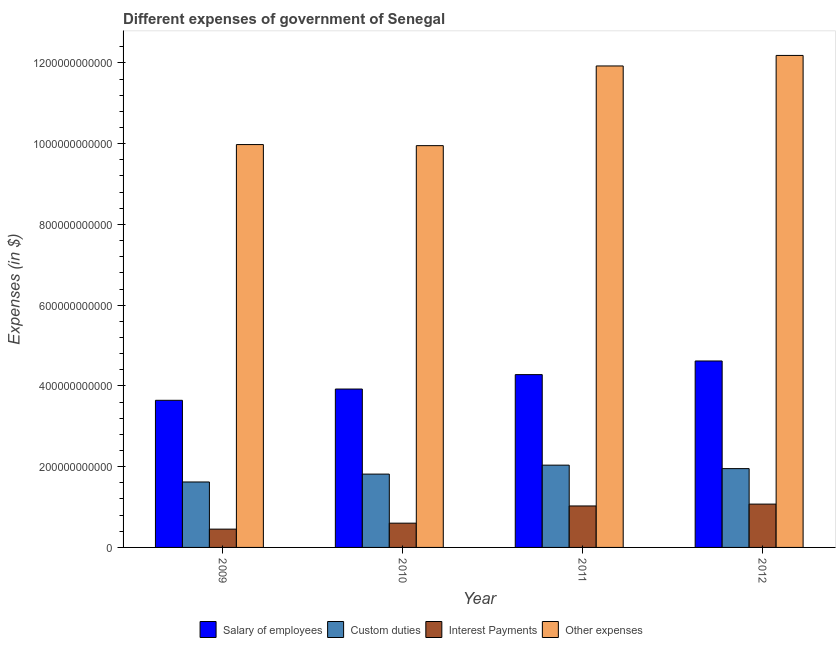How many different coloured bars are there?
Your response must be concise. 4. How many groups of bars are there?
Provide a succinct answer. 4. Are the number of bars on each tick of the X-axis equal?
Your response must be concise. Yes. How many bars are there on the 1st tick from the left?
Provide a short and direct response. 4. How many bars are there on the 4th tick from the right?
Keep it short and to the point. 4. What is the amount spent on custom duties in 2012?
Offer a terse response. 1.95e+11. Across all years, what is the maximum amount spent on custom duties?
Offer a terse response. 2.04e+11. Across all years, what is the minimum amount spent on interest payments?
Ensure brevity in your answer.  4.53e+1. In which year was the amount spent on interest payments maximum?
Your answer should be very brief. 2012. What is the total amount spent on salary of employees in the graph?
Offer a very short reply. 1.65e+12. What is the difference between the amount spent on other expenses in 2011 and that in 2012?
Your response must be concise. -2.61e+1. What is the difference between the amount spent on salary of employees in 2010 and the amount spent on interest payments in 2012?
Keep it short and to the point. -6.95e+1. What is the average amount spent on custom duties per year?
Keep it short and to the point. 1.86e+11. In the year 2010, what is the difference between the amount spent on interest payments and amount spent on salary of employees?
Provide a succinct answer. 0. In how many years, is the amount spent on interest payments greater than 760000000000 $?
Offer a terse response. 0. What is the ratio of the amount spent on salary of employees in 2010 to that in 2011?
Your answer should be compact. 0.92. What is the difference between the highest and the second highest amount spent on salary of employees?
Provide a succinct answer. 3.38e+1. What is the difference between the highest and the lowest amount spent on interest payments?
Keep it short and to the point. 6.20e+1. In how many years, is the amount spent on salary of employees greater than the average amount spent on salary of employees taken over all years?
Ensure brevity in your answer.  2. Is the sum of the amount spent on salary of employees in 2010 and 2012 greater than the maximum amount spent on interest payments across all years?
Make the answer very short. Yes. What does the 3rd bar from the left in 2012 represents?
Your response must be concise. Interest Payments. What does the 2nd bar from the right in 2009 represents?
Keep it short and to the point. Interest Payments. What is the difference between two consecutive major ticks on the Y-axis?
Offer a terse response. 2.00e+11. Are the values on the major ticks of Y-axis written in scientific E-notation?
Keep it short and to the point. No. Does the graph contain any zero values?
Your answer should be compact. No. How are the legend labels stacked?
Your answer should be very brief. Horizontal. What is the title of the graph?
Provide a succinct answer. Different expenses of government of Senegal. Does "Mammal species" appear as one of the legend labels in the graph?
Your answer should be very brief. No. What is the label or title of the Y-axis?
Your response must be concise. Expenses (in $). What is the Expenses (in $) of Salary of employees in 2009?
Your response must be concise. 3.64e+11. What is the Expenses (in $) in Custom duties in 2009?
Your answer should be compact. 1.62e+11. What is the Expenses (in $) of Interest Payments in 2009?
Your answer should be compact. 4.53e+1. What is the Expenses (in $) in Other expenses in 2009?
Provide a short and direct response. 9.98e+11. What is the Expenses (in $) in Salary of employees in 2010?
Give a very brief answer. 3.92e+11. What is the Expenses (in $) in Custom duties in 2010?
Your answer should be compact. 1.82e+11. What is the Expenses (in $) of Interest Payments in 2010?
Provide a short and direct response. 6.01e+1. What is the Expenses (in $) in Other expenses in 2010?
Make the answer very short. 9.95e+11. What is the Expenses (in $) of Salary of employees in 2011?
Keep it short and to the point. 4.28e+11. What is the Expenses (in $) in Custom duties in 2011?
Your answer should be very brief. 2.04e+11. What is the Expenses (in $) of Interest Payments in 2011?
Provide a succinct answer. 1.03e+11. What is the Expenses (in $) in Other expenses in 2011?
Make the answer very short. 1.19e+12. What is the Expenses (in $) of Salary of employees in 2012?
Give a very brief answer. 4.62e+11. What is the Expenses (in $) of Custom duties in 2012?
Make the answer very short. 1.95e+11. What is the Expenses (in $) of Interest Payments in 2012?
Your answer should be very brief. 1.07e+11. What is the Expenses (in $) in Other expenses in 2012?
Your response must be concise. 1.22e+12. Across all years, what is the maximum Expenses (in $) in Salary of employees?
Provide a succinct answer. 4.62e+11. Across all years, what is the maximum Expenses (in $) of Custom duties?
Your answer should be compact. 2.04e+11. Across all years, what is the maximum Expenses (in $) in Interest Payments?
Your answer should be compact. 1.07e+11. Across all years, what is the maximum Expenses (in $) of Other expenses?
Your response must be concise. 1.22e+12. Across all years, what is the minimum Expenses (in $) in Salary of employees?
Ensure brevity in your answer.  3.64e+11. Across all years, what is the minimum Expenses (in $) in Custom duties?
Offer a very short reply. 1.62e+11. Across all years, what is the minimum Expenses (in $) in Interest Payments?
Offer a terse response. 4.53e+1. Across all years, what is the minimum Expenses (in $) of Other expenses?
Offer a very short reply. 9.95e+11. What is the total Expenses (in $) in Salary of employees in the graph?
Your answer should be compact. 1.65e+12. What is the total Expenses (in $) in Custom duties in the graph?
Your answer should be compact. 7.43e+11. What is the total Expenses (in $) of Interest Payments in the graph?
Give a very brief answer. 3.15e+11. What is the total Expenses (in $) in Other expenses in the graph?
Offer a very short reply. 4.40e+12. What is the difference between the Expenses (in $) of Salary of employees in 2009 and that in 2010?
Provide a short and direct response. -2.79e+1. What is the difference between the Expenses (in $) in Custom duties in 2009 and that in 2010?
Your answer should be very brief. -1.95e+1. What is the difference between the Expenses (in $) in Interest Payments in 2009 and that in 2010?
Your answer should be very brief. -1.48e+1. What is the difference between the Expenses (in $) of Other expenses in 2009 and that in 2010?
Provide a short and direct response. 2.67e+09. What is the difference between the Expenses (in $) of Salary of employees in 2009 and that in 2011?
Keep it short and to the point. -6.36e+1. What is the difference between the Expenses (in $) of Custom duties in 2009 and that in 2011?
Make the answer very short. -4.17e+1. What is the difference between the Expenses (in $) in Interest Payments in 2009 and that in 2011?
Provide a short and direct response. -5.74e+1. What is the difference between the Expenses (in $) in Other expenses in 2009 and that in 2011?
Give a very brief answer. -1.95e+11. What is the difference between the Expenses (in $) in Salary of employees in 2009 and that in 2012?
Your response must be concise. -9.74e+1. What is the difference between the Expenses (in $) of Custom duties in 2009 and that in 2012?
Your response must be concise. -3.31e+1. What is the difference between the Expenses (in $) in Interest Payments in 2009 and that in 2012?
Keep it short and to the point. -6.20e+1. What is the difference between the Expenses (in $) in Other expenses in 2009 and that in 2012?
Offer a terse response. -2.21e+11. What is the difference between the Expenses (in $) in Salary of employees in 2010 and that in 2011?
Provide a short and direct response. -3.57e+1. What is the difference between the Expenses (in $) in Custom duties in 2010 and that in 2011?
Provide a short and direct response. -2.22e+1. What is the difference between the Expenses (in $) of Interest Payments in 2010 and that in 2011?
Ensure brevity in your answer.  -4.26e+1. What is the difference between the Expenses (in $) in Other expenses in 2010 and that in 2011?
Provide a short and direct response. -1.97e+11. What is the difference between the Expenses (in $) of Salary of employees in 2010 and that in 2012?
Offer a very short reply. -6.95e+1. What is the difference between the Expenses (in $) in Custom duties in 2010 and that in 2012?
Offer a very short reply. -1.36e+1. What is the difference between the Expenses (in $) of Interest Payments in 2010 and that in 2012?
Offer a terse response. -4.72e+1. What is the difference between the Expenses (in $) in Other expenses in 2010 and that in 2012?
Keep it short and to the point. -2.23e+11. What is the difference between the Expenses (in $) in Salary of employees in 2011 and that in 2012?
Your response must be concise. -3.38e+1. What is the difference between the Expenses (in $) in Custom duties in 2011 and that in 2012?
Your response must be concise. 8.60e+09. What is the difference between the Expenses (in $) in Interest Payments in 2011 and that in 2012?
Your response must be concise. -4.60e+09. What is the difference between the Expenses (in $) in Other expenses in 2011 and that in 2012?
Offer a terse response. -2.61e+1. What is the difference between the Expenses (in $) of Salary of employees in 2009 and the Expenses (in $) of Custom duties in 2010?
Offer a very short reply. 1.83e+11. What is the difference between the Expenses (in $) in Salary of employees in 2009 and the Expenses (in $) in Interest Payments in 2010?
Your response must be concise. 3.04e+11. What is the difference between the Expenses (in $) in Salary of employees in 2009 and the Expenses (in $) in Other expenses in 2010?
Make the answer very short. -6.31e+11. What is the difference between the Expenses (in $) of Custom duties in 2009 and the Expenses (in $) of Interest Payments in 2010?
Make the answer very short. 1.02e+11. What is the difference between the Expenses (in $) of Custom duties in 2009 and the Expenses (in $) of Other expenses in 2010?
Your answer should be compact. -8.33e+11. What is the difference between the Expenses (in $) in Interest Payments in 2009 and the Expenses (in $) in Other expenses in 2010?
Offer a terse response. -9.50e+11. What is the difference between the Expenses (in $) of Salary of employees in 2009 and the Expenses (in $) of Custom duties in 2011?
Offer a very short reply. 1.61e+11. What is the difference between the Expenses (in $) of Salary of employees in 2009 and the Expenses (in $) of Interest Payments in 2011?
Provide a succinct answer. 2.62e+11. What is the difference between the Expenses (in $) of Salary of employees in 2009 and the Expenses (in $) of Other expenses in 2011?
Provide a short and direct response. -8.28e+11. What is the difference between the Expenses (in $) in Custom duties in 2009 and the Expenses (in $) in Interest Payments in 2011?
Your response must be concise. 5.94e+1. What is the difference between the Expenses (in $) of Custom duties in 2009 and the Expenses (in $) of Other expenses in 2011?
Offer a terse response. -1.03e+12. What is the difference between the Expenses (in $) in Interest Payments in 2009 and the Expenses (in $) in Other expenses in 2011?
Offer a very short reply. -1.15e+12. What is the difference between the Expenses (in $) of Salary of employees in 2009 and the Expenses (in $) of Custom duties in 2012?
Offer a very short reply. 1.69e+11. What is the difference between the Expenses (in $) of Salary of employees in 2009 and the Expenses (in $) of Interest Payments in 2012?
Provide a short and direct response. 2.57e+11. What is the difference between the Expenses (in $) in Salary of employees in 2009 and the Expenses (in $) in Other expenses in 2012?
Ensure brevity in your answer.  -8.54e+11. What is the difference between the Expenses (in $) in Custom duties in 2009 and the Expenses (in $) in Interest Payments in 2012?
Your response must be concise. 5.48e+1. What is the difference between the Expenses (in $) in Custom duties in 2009 and the Expenses (in $) in Other expenses in 2012?
Offer a terse response. -1.06e+12. What is the difference between the Expenses (in $) of Interest Payments in 2009 and the Expenses (in $) of Other expenses in 2012?
Provide a short and direct response. -1.17e+12. What is the difference between the Expenses (in $) in Salary of employees in 2010 and the Expenses (in $) in Custom duties in 2011?
Offer a terse response. 1.89e+11. What is the difference between the Expenses (in $) in Salary of employees in 2010 and the Expenses (in $) in Interest Payments in 2011?
Give a very brief answer. 2.90e+11. What is the difference between the Expenses (in $) in Salary of employees in 2010 and the Expenses (in $) in Other expenses in 2011?
Ensure brevity in your answer.  -8.00e+11. What is the difference between the Expenses (in $) in Custom duties in 2010 and the Expenses (in $) in Interest Payments in 2011?
Give a very brief answer. 7.89e+1. What is the difference between the Expenses (in $) in Custom duties in 2010 and the Expenses (in $) in Other expenses in 2011?
Keep it short and to the point. -1.01e+12. What is the difference between the Expenses (in $) of Interest Payments in 2010 and the Expenses (in $) of Other expenses in 2011?
Make the answer very short. -1.13e+12. What is the difference between the Expenses (in $) of Salary of employees in 2010 and the Expenses (in $) of Custom duties in 2012?
Your answer should be compact. 1.97e+11. What is the difference between the Expenses (in $) of Salary of employees in 2010 and the Expenses (in $) of Interest Payments in 2012?
Offer a terse response. 2.85e+11. What is the difference between the Expenses (in $) in Salary of employees in 2010 and the Expenses (in $) in Other expenses in 2012?
Your answer should be very brief. -8.26e+11. What is the difference between the Expenses (in $) in Custom duties in 2010 and the Expenses (in $) in Interest Payments in 2012?
Ensure brevity in your answer.  7.43e+1. What is the difference between the Expenses (in $) of Custom duties in 2010 and the Expenses (in $) of Other expenses in 2012?
Your answer should be very brief. -1.04e+12. What is the difference between the Expenses (in $) in Interest Payments in 2010 and the Expenses (in $) in Other expenses in 2012?
Provide a short and direct response. -1.16e+12. What is the difference between the Expenses (in $) in Salary of employees in 2011 and the Expenses (in $) in Custom duties in 2012?
Provide a short and direct response. 2.33e+11. What is the difference between the Expenses (in $) in Salary of employees in 2011 and the Expenses (in $) in Interest Payments in 2012?
Provide a short and direct response. 3.21e+11. What is the difference between the Expenses (in $) in Salary of employees in 2011 and the Expenses (in $) in Other expenses in 2012?
Provide a succinct answer. -7.91e+11. What is the difference between the Expenses (in $) of Custom duties in 2011 and the Expenses (in $) of Interest Payments in 2012?
Ensure brevity in your answer.  9.65e+1. What is the difference between the Expenses (in $) of Custom duties in 2011 and the Expenses (in $) of Other expenses in 2012?
Offer a very short reply. -1.01e+12. What is the difference between the Expenses (in $) in Interest Payments in 2011 and the Expenses (in $) in Other expenses in 2012?
Offer a very short reply. -1.12e+12. What is the average Expenses (in $) in Salary of employees per year?
Give a very brief answer. 4.12e+11. What is the average Expenses (in $) in Custom duties per year?
Offer a terse response. 1.86e+11. What is the average Expenses (in $) of Interest Payments per year?
Your answer should be compact. 7.88e+1. What is the average Expenses (in $) in Other expenses per year?
Your answer should be very brief. 1.10e+12. In the year 2009, what is the difference between the Expenses (in $) in Salary of employees and Expenses (in $) in Custom duties?
Offer a very short reply. 2.02e+11. In the year 2009, what is the difference between the Expenses (in $) in Salary of employees and Expenses (in $) in Interest Payments?
Keep it short and to the point. 3.19e+11. In the year 2009, what is the difference between the Expenses (in $) of Salary of employees and Expenses (in $) of Other expenses?
Your answer should be very brief. -6.33e+11. In the year 2009, what is the difference between the Expenses (in $) of Custom duties and Expenses (in $) of Interest Payments?
Offer a terse response. 1.17e+11. In the year 2009, what is the difference between the Expenses (in $) in Custom duties and Expenses (in $) in Other expenses?
Keep it short and to the point. -8.36e+11. In the year 2009, what is the difference between the Expenses (in $) in Interest Payments and Expenses (in $) in Other expenses?
Offer a terse response. -9.52e+11. In the year 2010, what is the difference between the Expenses (in $) of Salary of employees and Expenses (in $) of Custom duties?
Offer a very short reply. 2.11e+11. In the year 2010, what is the difference between the Expenses (in $) of Salary of employees and Expenses (in $) of Interest Payments?
Offer a very short reply. 3.32e+11. In the year 2010, what is the difference between the Expenses (in $) in Salary of employees and Expenses (in $) in Other expenses?
Your answer should be very brief. -6.03e+11. In the year 2010, what is the difference between the Expenses (in $) of Custom duties and Expenses (in $) of Interest Payments?
Keep it short and to the point. 1.22e+11. In the year 2010, what is the difference between the Expenses (in $) in Custom duties and Expenses (in $) in Other expenses?
Give a very brief answer. -8.14e+11. In the year 2010, what is the difference between the Expenses (in $) in Interest Payments and Expenses (in $) in Other expenses?
Make the answer very short. -9.35e+11. In the year 2011, what is the difference between the Expenses (in $) of Salary of employees and Expenses (in $) of Custom duties?
Provide a succinct answer. 2.24e+11. In the year 2011, what is the difference between the Expenses (in $) in Salary of employees and Expenses (in $) in Interest Payments?
Offer a very short reply. 3.25e+11. In the year 2011, what is the difference between the Expenses (in $) of Salary of employees and Expenses (in $) of Other expenses?
Your response must be concise. -7.64e+11. In the year 2011, what is the difference between the Expenses (in $) in Custom duties and Expenses (in $) in Interest Payments?
Make the answer very short. 1.01e+11. In the year 2011, what is the difference between the Expenses (in $) in Custom duties and Expenses (in $) in Other expenses?
Make the answer very short. -9.89e+11. In the year 2011, what is the difference between the Expenses (in $) in Interest Payments and Expenses (in $) in Other expenses?
Keep it short and to the point. -1.09e+12. In the year 2012, what is the difference between the Expenses (in $) of Salary of employees and Expenses (in $) of Custom duties?
Provide a succinct answer. 2.67e+11. In the year 2012, what is the difference between the Expenses (in $) of Salary of employees and Expenses (in $) of Interest Payments?
Make the answer very short. 3.54e+11. In the year 2012, what is the difference between the Expenses (in $) in Salary of employees and Expenses (in $) in Other expenses?
Provide a succinct answer. -7.57e+11. In the year 2012, what is the difference between the Expenses (in $) of Custom duties and Expenses (in $) of Interest Payments?
Make the answer very short. 8.79e+1. In the year 2012, what is the difference between the Expenses (in $) of Custom duties and Expenses (in $) of Other expenses?
Offer a terse response. -1.02e+12. In the year 2012, what is the difference between the Expenses (in $) of Interest Payments and Expenses (in $) of Other expenses?
Your response must be concise. -1.11e+12. What is the ratio of the Expenses (in $) of Salary of employees in 2009 to that in 2010?
Provide a succinct answer. 0.93. What is the ratio of the Expenses (in $) of Custom duties in 2009 to that in 2010?
Offer a terse response. 0.89. What is the ratio of the Expenses (in $) in Interest Payments in 2009 to that in 2010?
Make the answer very short. 0.75. What is the ratio of the Expenses (in $) of Salary of employees in 2009 to that in 2011?
Your response must be concise. 0.85. What is the ratio of the Expenses (in $) of Custom duties in 2009 to that in 2011?
Give a very brief answer. 0.8. What is the ratio of the Expenses (in $) of Interest Payments in 2009 to that in 2011?
Your answer should be very brief. 0.44. What is the ratio of the Expenses (in $) of Other expenses in 2009 to that in 2011?
Your answer should be compact. 0.84. What is the ratio of the Expenses (in $) in Salary of employees in 2009 to that in 2012?
Provide a short and direct response. 0.79. What is the ratio of the Expenses (in $) of Custom duties in 2009 to that in 2012?
Offer a very short reply. 0.83. What is the ratio of the Expenses (in $) in Interest Payments in 2009 to that in 2012?
Your answer should be very brief. 0.42. What is the ratio of the Expenses (in $) of Other expenses in 2009 to that in 2012?
Offer a very short reply. 0.82. What is the ratio of the Expenses (in $) in Salary of employees in 2010 to that in 2011?
Offer a very short reply. 0.92. What is the ratio of the Expenses (in $) of Custom duties in 2010 to that in 2011?
Your answer should be compact. 0.89. What is the ratio of the Expenses (in $) in Interest Payments in 2010 to that in 2011?
Give a very brief answer. 0.58. What is the ratio of the Expenses (in $) in Other expenses in 2010 to that in 2011?
Make the answer very short. 0.83. What is the ratio of the Expenses (in $) of Salary of employees in 2010 to that in 2012?
Your response must be concise. 0.85. What is the ratio of the Expenses (in $) in Custom duties in 2010 to that in 2012?
Your response must be concise. 0.93. What is the ratio of the Expenses (in $) in Interest Payments in 2010 to that in 2012?
Offer a very short reply. 0.56. What is the ratio of the Expenses (in $) in Other expenses in 2010 to that in 2012?
Your response must be concise. 0.82. What is the ratio of the Expenses (in $) in Salary of employees in 2011 to that in 2012?
Your answer should be very brief. 0.93. What is the ratio of the Expenses (in $) of Custom duties in 2011 to that in 2012?
Give a very brief answer. 1.04. What is the ratio of the Expenses (in $) in Interest Payments in 2011 to that in 2012?
Offer a terse response. 0.96. What is the ratio of the Expenses (in $) of Other expenses in 2011 to that in 2012?
Make the answer very short. 0.98. What is the difference between the highest and the second highest Expenses (in $) of Salary of employees?
Make the answer very short. 3.38e+1. What is the difference between the highest and the second highest Expenses (in $) in Custom duties?
Provide a succinct answer. 8.60e+09. What is the difference between the highest and the second highest Expenses (in $) in Interest Payments?
Your response must be concise. 4.60e+09. What is the difference between the highest and the second highest Expenses (in $) of Other expenses?
Your answer should be very brief. 2.61e+1. What is the difference between the highest and the lowest Expenses (in $) in Salary of employees?
Your answer should be very brief. 9.74e+1. What is the difference between the highest and the lowest Expenses (in $) in Custom duties?
Give a very brief answer. 4.17e+1. What is the difference between the highest and the lowest Expenses (in $) of Interest Payments?
Make the answer very short. 6.20e+1. What is the difference between the highest and the lowest Expenses (in $) of Other expenses?
Your answer should be very brief. 2.23e+11. 